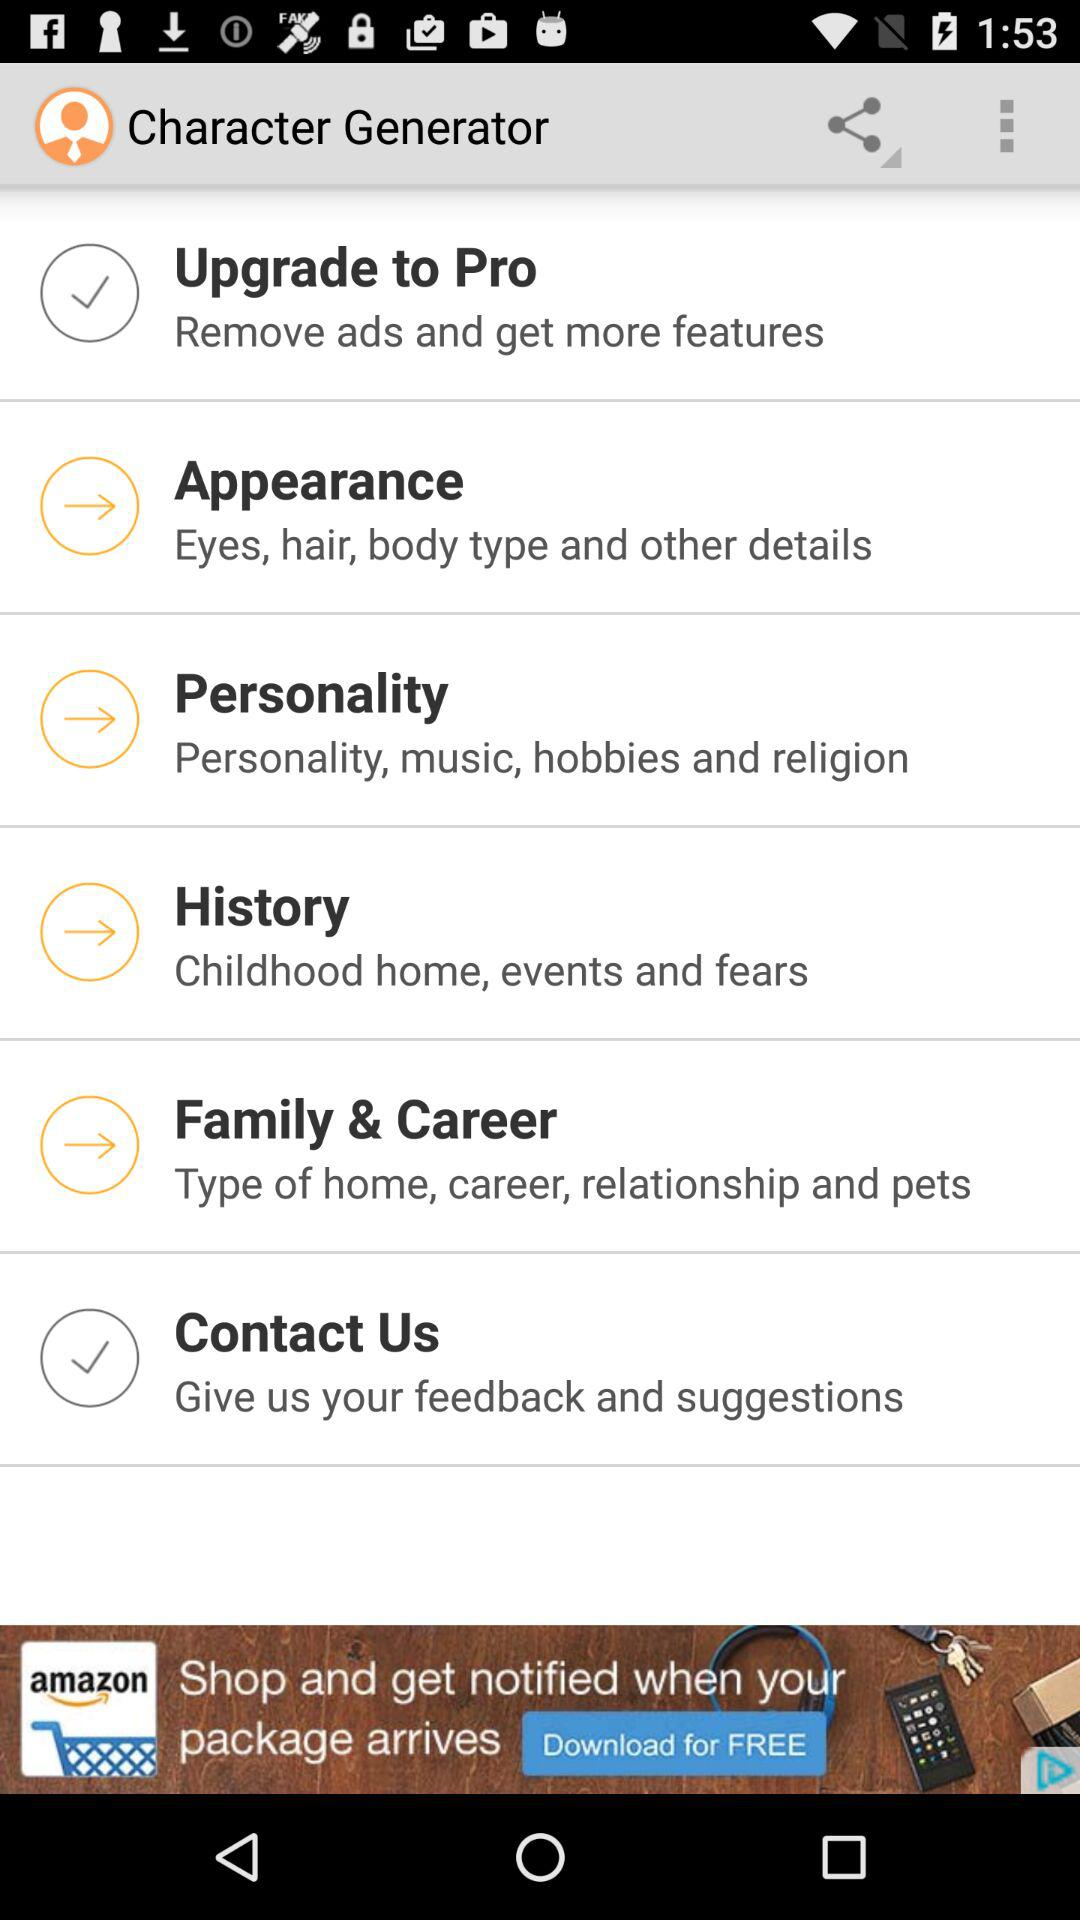What is the name of the application? The name of the application is "Character Generator". 